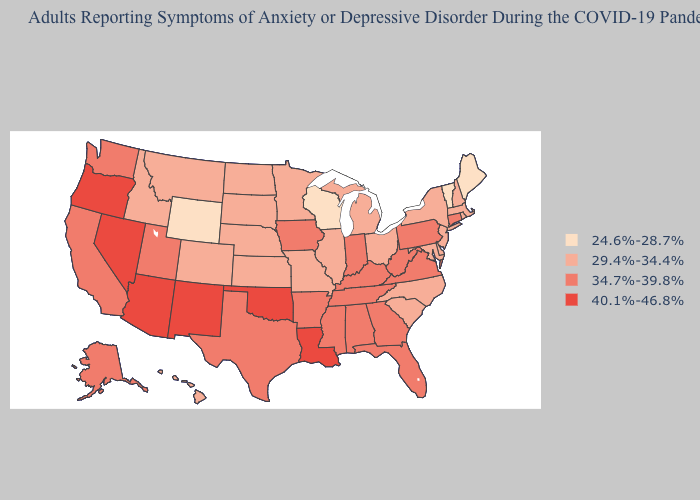What is the highest value in the USA?
Concise answer only. 40.1%-46.8%. Does New York have the same value as Arkansas?
Give a very brief answer. No. How many symbols are there in the legend?
Concise answer only. 4. What is the highest value in states that border Arkansas?
Keep it brief. 40.1%-46.8%. How many symbols are there in the legend?
Short answer required. 4. What is the value of South Carolina?
Short answer required. 29.4%-34.4%. Name the states that have a value in the range 40.1%-46.8%?
Short answer required. Arizona, Louisiana, Nevada, New Mexico, Oklahoma, Oregon. Name the states that have a value in the range 24.6%-28.7%?
Write a very short answer. Maine, Vermont, Wisconsin, Wyoming. Name the states that have a value in the range 24.6%-28.7%?
Short answer required. Maine, Vermont, Wisconsin, Wyoming. Does Ohio have the same value as North Dakota?
Write a very short answer. Yes. Which states hav the highest value in the MidWest?
Concise answer only. Indiana, Iowa. Does Connecticut have a higher value than Arizona?
Write a very short answer. No. What is the value of Mississippi?
Quick response, please. 34.7%-39.8%. Does Wyoming have a higher value than Nebraska?
Give a very brief answer. No. What is the lowest value in the South?
Keep it brief. 29.4%-34.4%. 